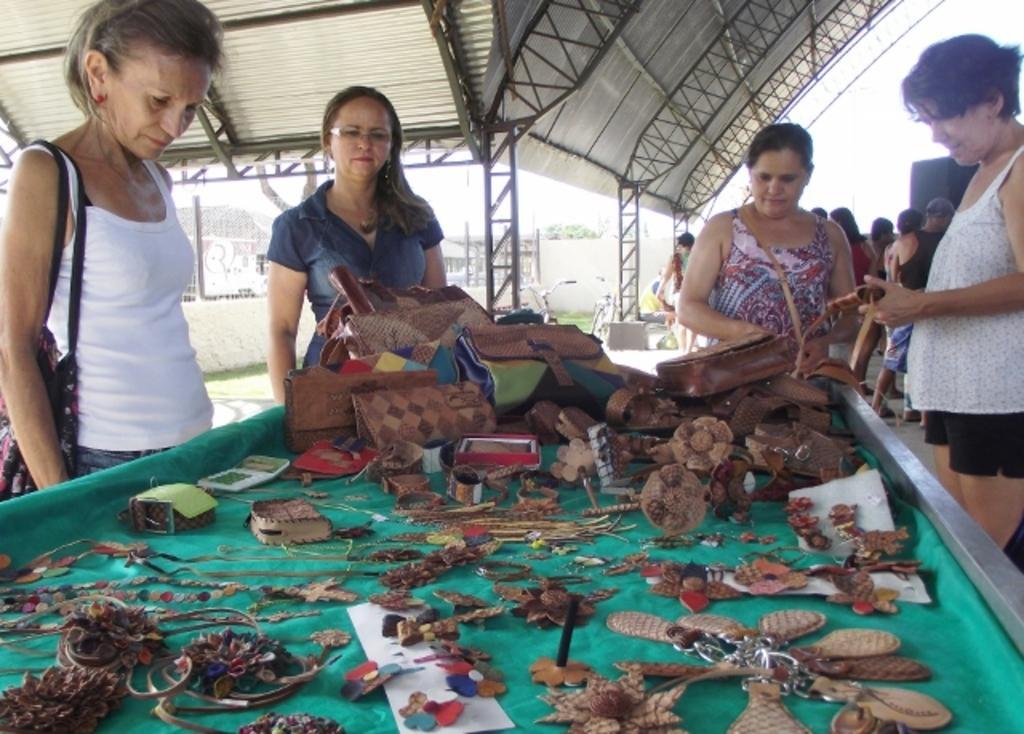Describe this image in one or two sentences. In this picture there is a group of women, standing and looking to the green color table on which many wooden craft key chain and lockets are placed. On the top we can see the metal frame with shed. 